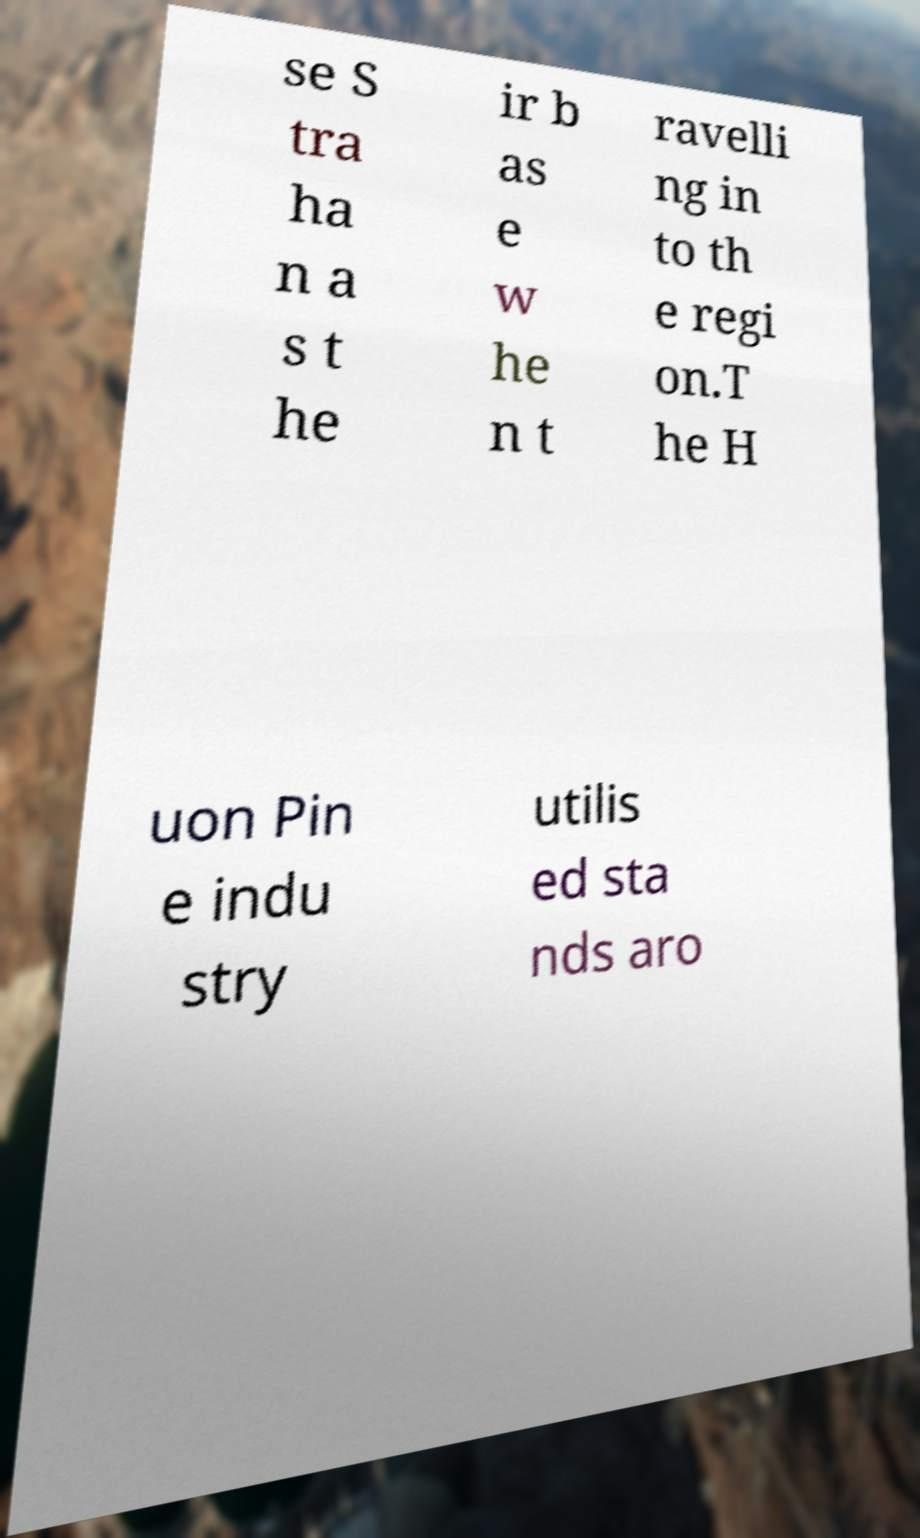I need the written content from this picture converted into text. Can you do that? se S tra ha n a s t he ir b as e w he n t ravelli ng in to th e regi on.T he H uon Pin e indu stry utilis ed sta nds aro 